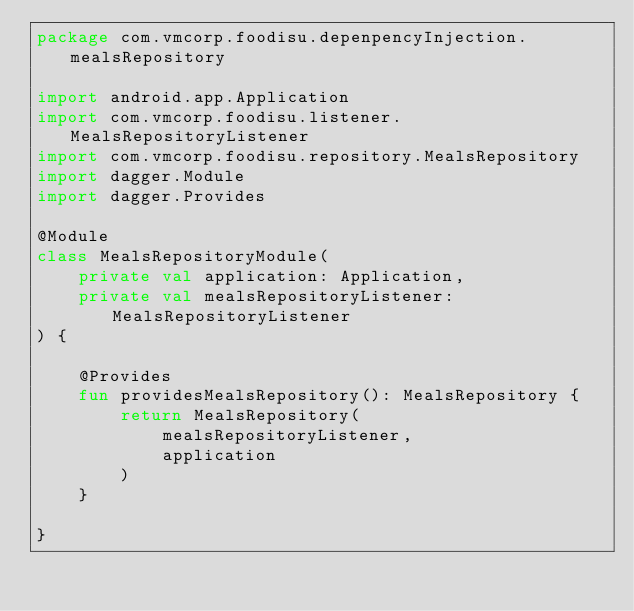Convert code to text. <code><loc_0><loc_0><loc_500><loc_500><_Kotlin_>package com.vmcorp.foodisu.depenpencyInjection.mealsRepository

import android.app.Application
import com.vmcorp.foodisu.listener.MealsRepositoryListener
import com.vmcorp.foodisu.repository.MealsRepository
import dagger.Module
import dagger.Provides

@Module
class MealsRepositoryModule(
    private val application: Application,
    private val mealsRepositoryListener: MealsRepositoryListener
) {

    @Provides
    fun providesMealsRepository(): MealsRepository {
        return MealsRepository(
            mealsRepositoryListener,
            application
        )
    }

}</code> 